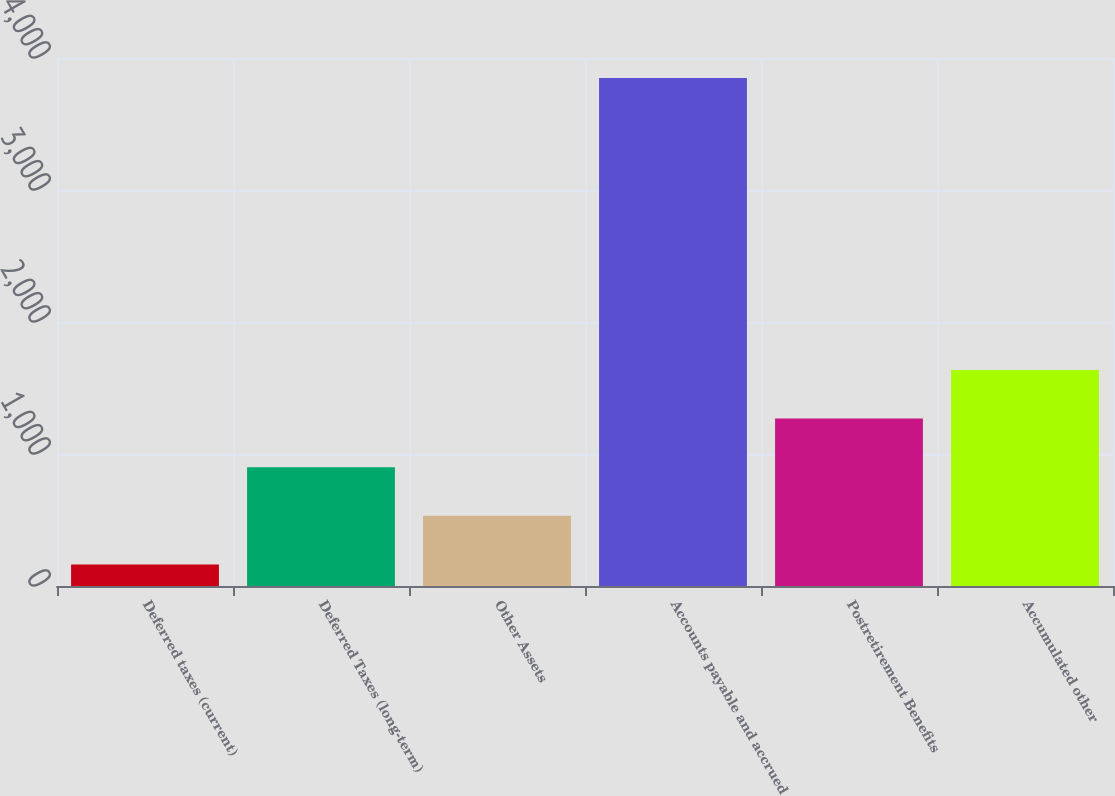Convert chart. <chart><loc_0><loc_0><loc_500><loc_500><bar_chart><fcel>Deferred taxes (current)<fcel>Deferred Taxes (long-term)<fcel>Other Assets<fcel>Accounts payable and accrued<fcel>Postretirement Benefits<fcel>Accumulated other<nl><fcel>163<fcel>900<fcel>531.5<fcel>3848<fcel>1268.5<fcel>1637<nl></chart> 